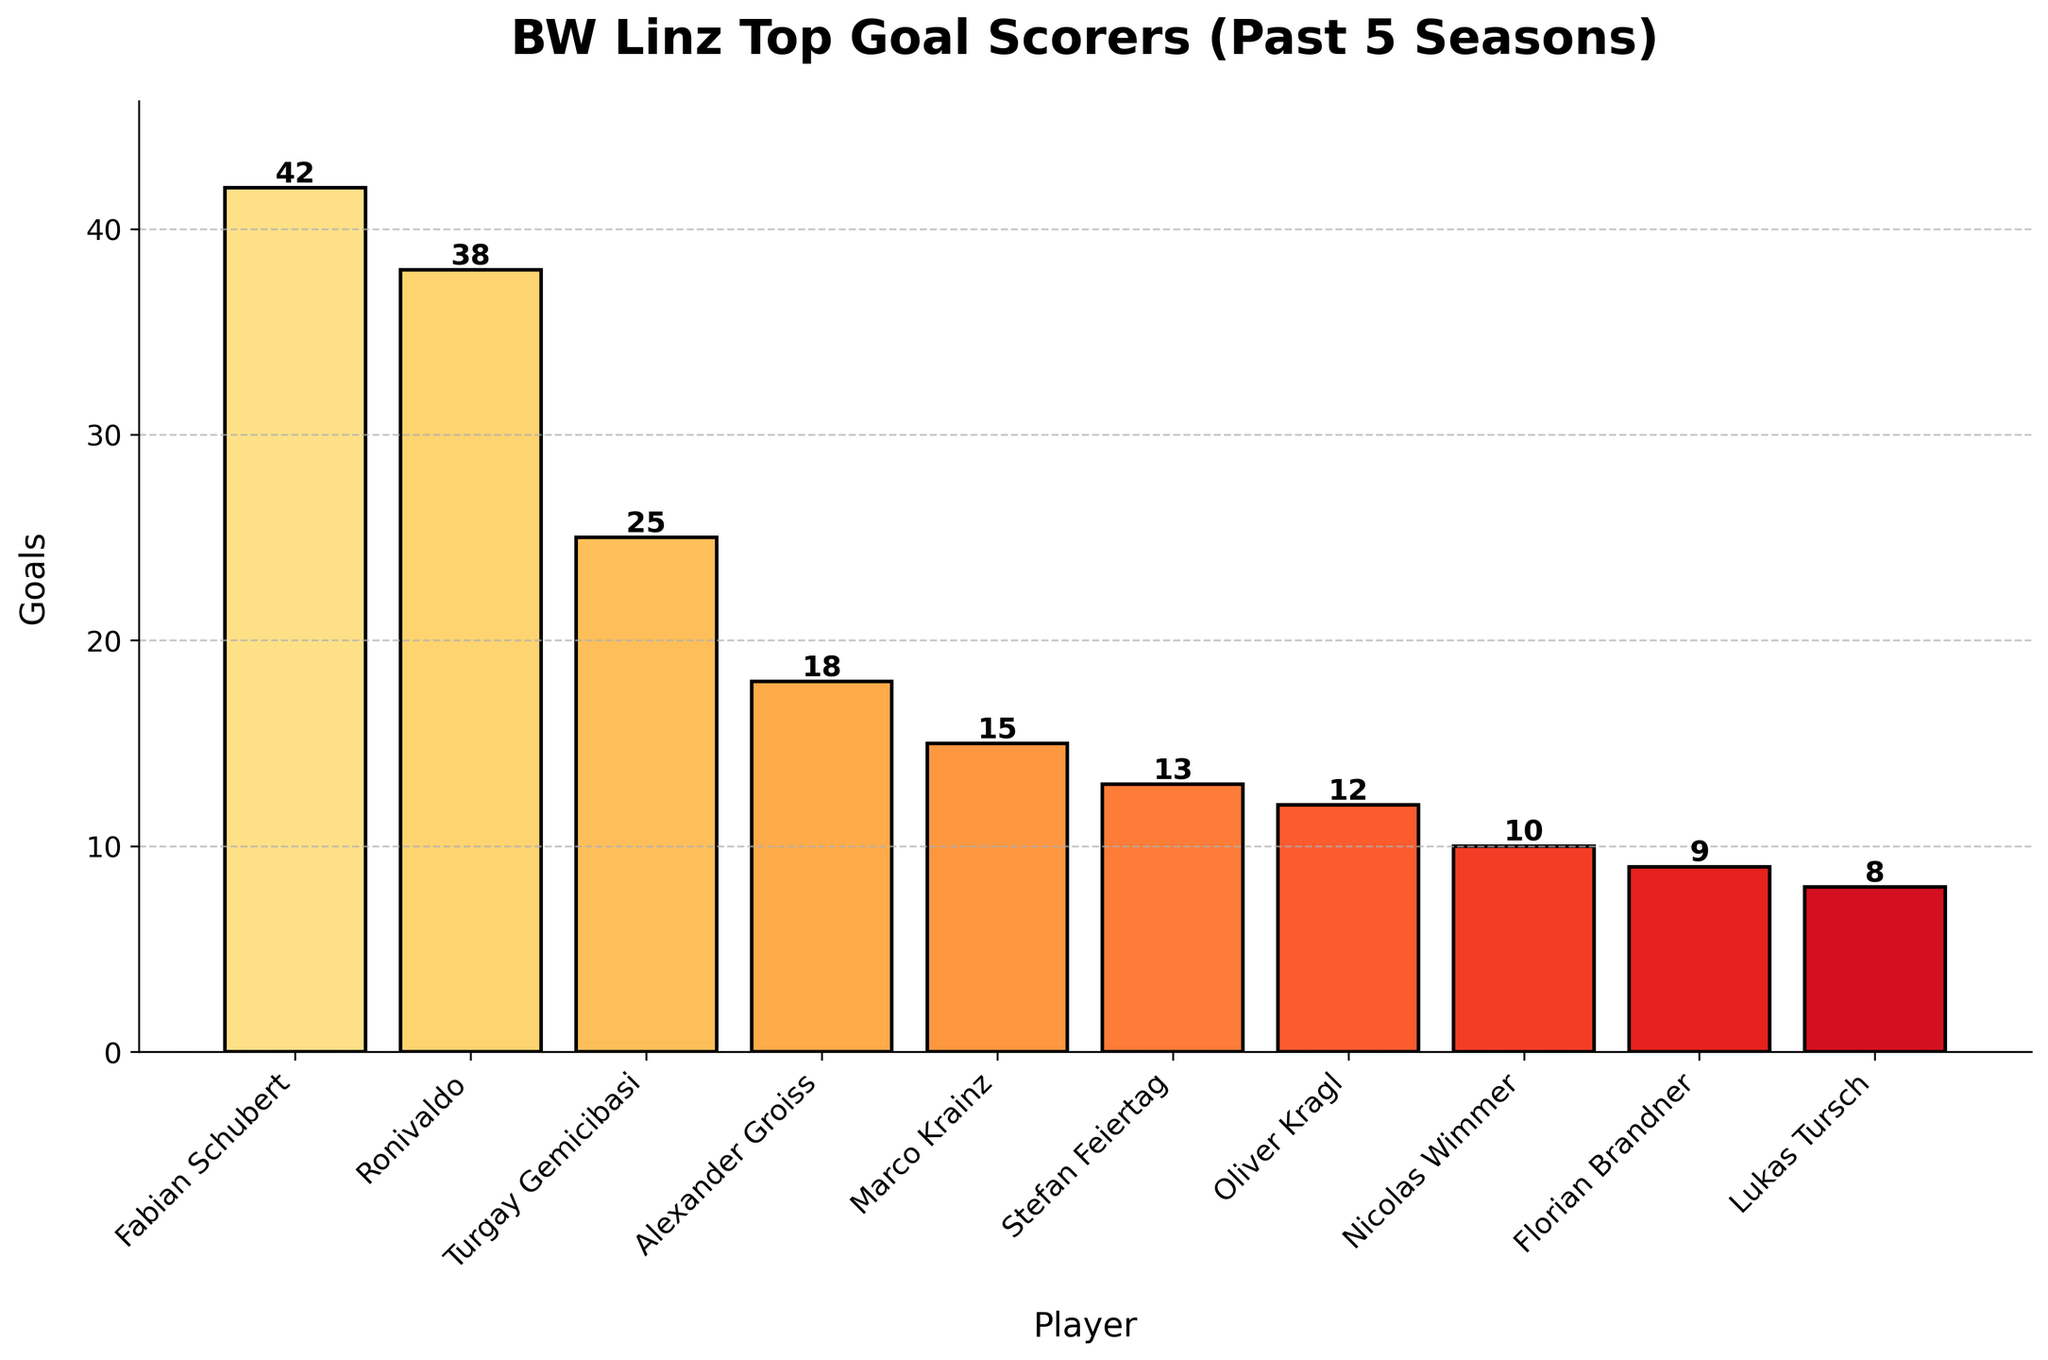What's the total number of goals scored by the top three players combined? First, identify the goals scored by each of the top three players: Fabian Schubert (42), Ronivaldo (38), and Turgay Gemicibasi (25). Add these goals together: 42 + 38 + 25 = 105.
Answer: 105 Who is the second highest goal scorer? Look at the bar heights and corresponding player names. The player with the second tallest bar is Ronivaldo, with 38 goals.
Answer: Ronivaldo How many more goals did Fabian Schubert score compared to Nicolas Wimmer? Find the goals for Fabian Schubert (42) and for Nicolas Wimmer (10). Subtract the smaller from the larger number: 42 - 10 = 32.
Answer: 32 What is the average number of goals scored by the players displayed? Calculate the total number of goals by summing the given values: 42 + 38 + 25 + 18 + 15 + 13 + 12 + 10 + 9 + 8 = 190. Divide by the number of players (10): 190 / 10 = 19.
Answer: 19 Which player has the fewest goals and how many did they score? Identify the shortest bar, corresponding to Lukas Tursch. He scored 8 goals.
Answer: Lukas Tursch, 8 How many goals separate the player with the highest goals from the player with the lowest goals? Find the goals for the highest scorer, Fabian Schubert (42), and the lowest scorer, Lukas Tursch (8). Subtract the smaller from the larger number: 42 - 8 = 34.
Answer: 34 What is the combined number of goals scored by players who have more than 20 goals each? Identify players with more than 20 goals: Fabian Schubert (42), Ronivaldo (38), and Turgay Gemicibasi (25). Sum these goals: 42 + 38 + 25 = 105.
Answer: 105 Compare the number of goals scored by Oliver Kragl and Stefan Feiertag. Who scored more and by how many? Look at the bar heights for Oliver Kragl (12) and Stefan Feiertag (13). Subtract the smaller number from the larger: 13 - 12 = 1. Stefan Feiertag scored 1 goal more.
Answer: Stefan Feiertag by 1 What is the range of goals scored among the players? Identify the highest and lowest goals scored: Fabian Schubert (42) and Lukas Tursch (8). Subtract the smallest from the largest: 42 - 8 = 34.
Answer: 34 